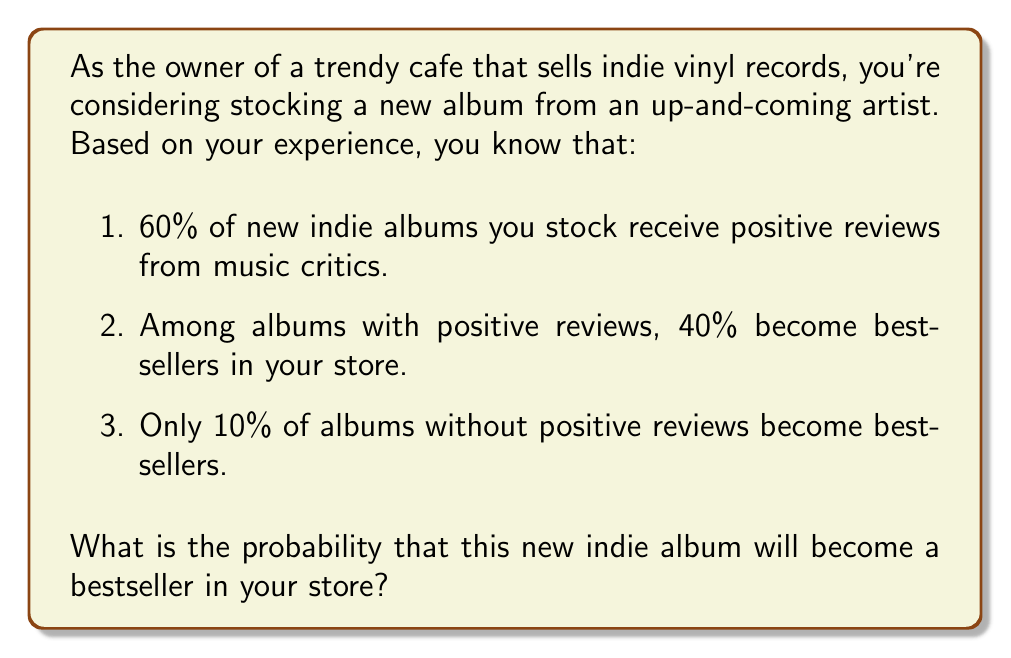Help me with this question. Let's approach this problem using the law of total probability. We'll define the following events:

$B$: The album becomes a bestseller
$P$: The album receives positive reviews

We're given the following probabilities:

$P(P) = 0.60$ (probability of receiving positive reviews)
$P(B|P) = 0.40$ (probability of becoming a bestseller given positive reviews)
$P(B|\neg P) = 0.10$ (probability of becoming a bestseller given no positive reviews)

The law of total probability states:

$$P(B) = P(B|P) \cdot P(P) + P(B|\neg P) \cdot P(\neg P)$$

We know $P(P) = 0.60$, so $P(\neg P) = 1 - P(P) = 0.40$

Let's substitute the values:

$$\begin{align}
P(B) &= 0.40 \cdot 0.60 + 0.10 \cdot 0.40 \\
&= 0.24 + 0.04 \\
&= 0.28
\end{align}$$

Therefore, the probability that the new indie album will become a bestseller in your store is 0.28 or 28%.
Answer: 0.28 or 28% 